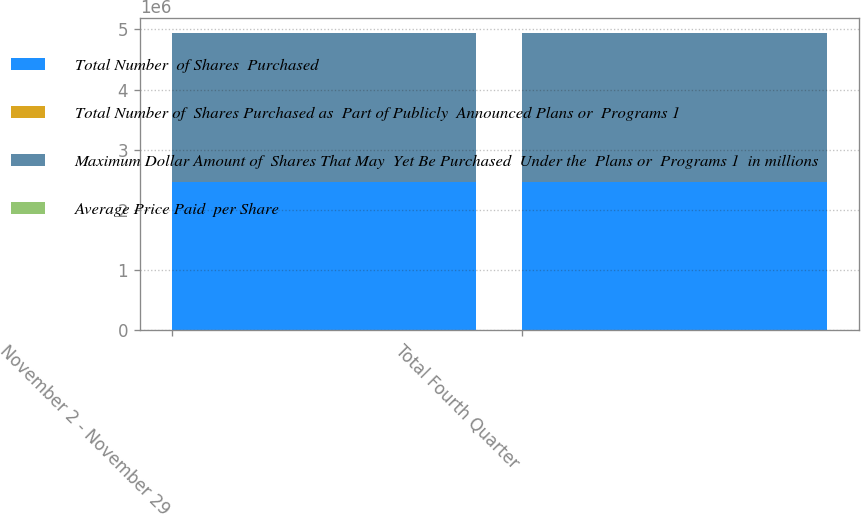Convert chart to OTSL. <chart><loc_0><loc_0><loc_500><loc_500><stacked_bar_chart><ecel><fcel>November 2 - November 29<fcel>Total Fourth Quarter<nl><fcel>Total Number  of Shares  Purchased<fcel>2.4673e+06<fcel>2.4673e+06<nl><fcel>Total Number of  Shares Purchased as  Part of Publicly  Announced Plans or  Programs 1<fcel>34.59<fcel>34.59<nl><fcel>Maximum Dollar Amount of  Shares That May  Yet Be Purchased  Under the  Plans or  Programs 1  in millions<fcel>2.4673e+06<fcel>2.4673e+06<nl><fcel>Average Price Paid  per Share<fcel>414.7<fcel>414.7<nl></chart> 